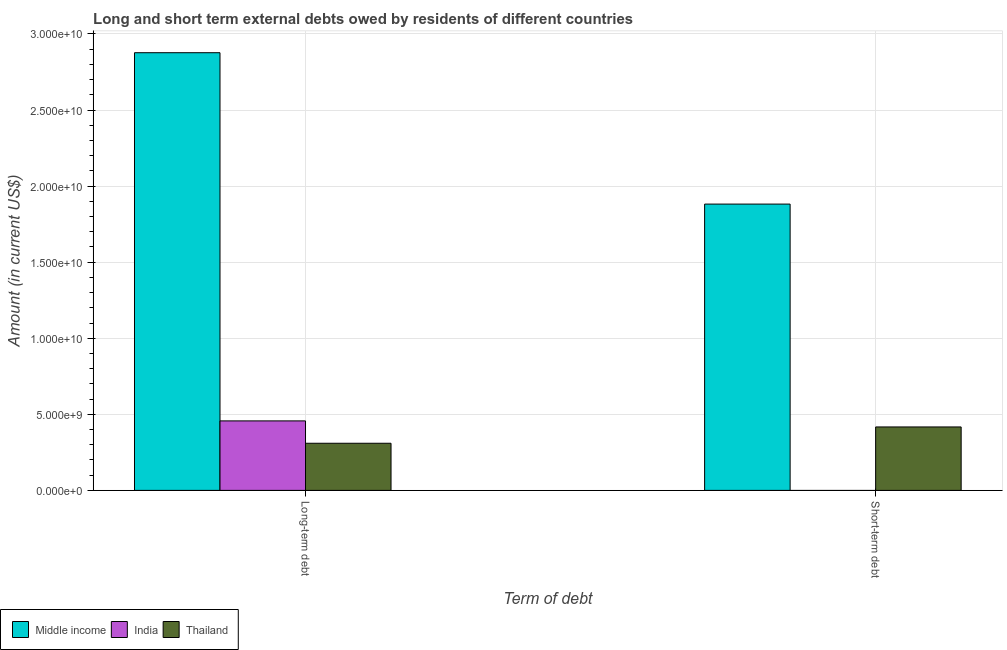Are the number of bars per tick equal to the number of legend labels?
Ensure brevity in your answer.  No. Are the number of bars on each tick of the X-axis equal?
Your answer should be very brief. No. How many bars are there on the 1st tick from the left?
Offer a terse response. 3. What is the label of the 2nd group of bars from the left?
Give a very brief answer. Short-term debt. What is the long-term debts owed by residents in Thailand?
Your response must be concise. 3.10e+09. Across all countries, what is the maximum long-term debts owed by residents?
Give a very brief answer. 2.88e+1. Across all countries, what is the minimum short-term debts owed by residents?
Your response must be concise. 0. What is the total short-term debts owed by residents in the graph?
Provide a succinct answer. 2.30e+1. What is the difference between the short-term debts owed by residents in Middle income and that in Thailand?
Ensure brevity in your answer.  1.46e+1. What is the difference between the short-term debts owed by residents in Middle income and the long-term debts owed by residents in Thailand?
Provide a short and direct response. 1.57e+1. What is the average short-term debts owed by residents per country?
Give a very brief answer. 7.66e+09. What is the difference between the long-term debts owed by residents and short-term debts owed by residents in Middle income?
Keep it short and to the point. 9.95e+09. What is the ratio of the long-term debts owed by residents in Thailand to that in Middle income?
Your response must be concise. 0.11. In how many countries, is the short-term debts owed by residents greater than the average short-term debts owed by residents taken over all countries?
Your answer should be very brief. 1. How many bars are there?
Your answer should be compact. 5. Are all the bars in the graph horizontal?
Ensure brevity in your answer.  No. What is the difference between two consecutive major ticks on the Y-axis?
Ensure brevity in your answer.  5.00e+09. Are the values on the major ticks of Y-axis written in scientific E-notation?
Give a very brief answer. Yes. Does the graph contain any zero values?
Ensure brevity in your answer.  Yes. Does the graph contain grids?
Provide a short and direct response. Yes. How many legend labels are there?
Give a very brief answer. 3. How are the legend labels stacked?
Provide a short and direct response. Horizontal. What is the title of the graph?
Provide a succinct answer. Long and short term external debts owed by residents of different countries. What is the label or title of the X-axis?
Your answer should be very brief. Term of debt. What is the Amount (in current US$) of Middle income in Long-term debt?
Offer a very short reply. 2.88e+1. What is the Amount (in current US$) in India in Long-term debt?
Give a very brief answer. 4.57e+09. What is the Amount (in current US$) of Thailand in Long-term debt?
Offer a terse response. 3.10e+09. What is the Amount (in current US$) in Middle income in Short-term debt?
Give a very brief answer. 1.88e+1. What is the Amount (in current US$) of Thailand in Short-term debt?
Your response must be concise. 4.17e+09. Across all Term of debt, what is the maximum Amount (in current US$) of Middle income?
Give a very brief answer. 2.88e+1. Across all Term of debt, what is the maximum Amount (in current US$) of India?
Ensure brevity in your answer.  4.57e+09. Across all Term of debt, what is the maximum Amount (in current US$) of Thailand?
Your answer should be compact. 4.17e+09. Across all Term of debt, what is the minimum Amount (in current US$) in Middle income?
Make the answer very short. 1.88e+1. Across all Term of debt, what is the minimum Amount (in current US$) of India?
Your answer should be very brief. 0. Across all Term of debt, what is the minimum Amount (in current US$) of Thailand?
Your answer should be compact. 3.10e+09. What is the total Amount (in current US$) of Middle income in the graph?
Your answer should be compact. 4.76e+1. What is the total Amount (in current US$) in India in the graph?
Make the answer very short. 4.57e+09. What is the total Amount (in current US$) in Thailand in the graph?
Provide a succinct answer. 7.27e+09. What is the difference between the Amount (in current US$) in Middle income in Long-term debt and that in Short-term debt?
Offer a terse response. 9.95e+09. What is the difference between the Amount (in current US$) of Thailand in Long-term debt and that in Short-term debt?
Ensure brevity in your answer.  -1.07e+09. What is the difference between the Amount (in current US$) in Middle income in Long-term debt and the Amount (in current US$) in Thailand in Short-term debt?
Ensure brevity in your answer.  2.46e+1. What is the difference between the Amount (in current US$) of India in Long-term debt and the Amount (in current US$) of Thailand in Short-term debt?
Provide a succinct answer. 3.97e+08. What is the average Amount (in current US$) of Middle income per Term of debt?
Give a very brief answer. 2.38e+1. What is the average Amount (in current US$) in India per Term of debt?
Your answer should be very brief. 2.28e+09. What is the average Amount (in current US$) of Thailand per Term of debt?
Your answer should be compact. 3.63e+09. What is the difference between the Amount (in current US$) of Middle income and Amount (in current US$) of India in Long-term debt?
Your answer should be very brief. 2.42e+1. What is the difference between the Amount (in current US$) in Middle income and Amount (in current US$) in Thailand in Long-term debt?
Make the answer very short. 2.57e+1. What is the difference between the Amount (in current US$) in India and Amount (in current US$) in Thailand in Long-term debt?
Make the answer very short. 1.47e+09. What is the difference between the Amount (in current US$) of Middle income and Amount (in current US$) of Thailand in Short-term debt?
Your answer should be compact. 1.46e+1. What is the ratio of the Amount (in current US$) of Middle income in Long-term debt to that in Short-term debt?
Your answer should be compact. 1.53. What is the ratio of the Amount (in current US$) in Thailand in Long-term debt to that in Short-term debt?
Your answer should be compact. 0.74. What is the difference between the highest and the second highest Amount (in current US$) in Middle income?
Provide a succinct answer. 9.95e+09. What is the difference between the highest and the second highest Amount (in current US$) in Thailand?
Offer a terse response. 1.07e+09. What is the difference between the highest and the lowest Amount (in current US$) in Middle income?
Your answer should be compact. 9.95e+09. What is the difference between the highest and the lowest Amount (in current US$) in India?
Give a very brief answer. 4.57e+09. What is the difference between the highest and the lowest Amount (in current US$) in Thailand?
Offer a terse response. 1.07e+09. 